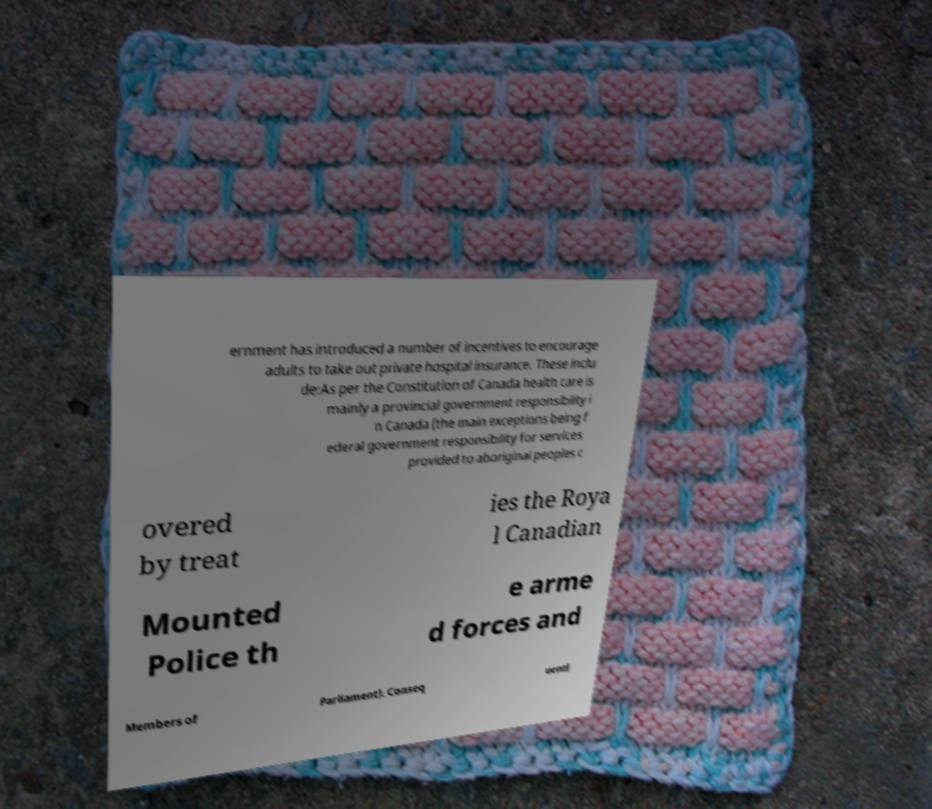Please identify and transcribe the text found in this image. ernment has introduced a number of incentives to encourage adults to take out private hospital insurance. These inclu de:As per the Constitution of Canada health care is mainly a provincial government responsibility i n Canada (the main exceptions being f ederal government responsibility for services provided to aboriginal peoples c overed by treat ies the Roya l Canadian Mounted Police th e arme d forces and Members of Parliament). Conseq uentl 